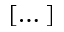<formula> <loc_0><loc_0><loc_500><loc_500>[ \dots ]</formula> 